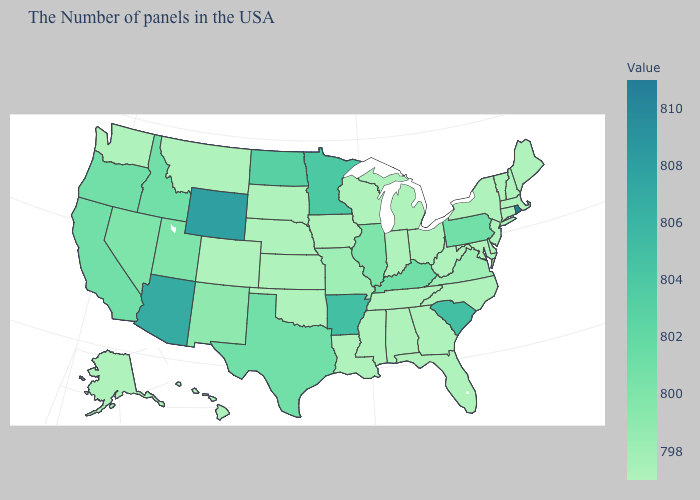Which states have the highest value in the USA?
Give a very brief answer. Rhode Island. Does Illinois have a higher value than Wisconsin?
Give a very brief answer. Yes. Which states have the highest value in the USA?
Be succinct. Rhode Island. Does Ohio have the highest value in the MidWest?
Quick response, please. No. Which states have the lowest value in the Northeast?
Write a very short answer. Maine, Massachusetts, New Hampshire, Vermont, Connecticut, New York, New Jersey. Does Florida have a lower value than Arkansas?
Write a very short answer. Yes. Does New Jersey have the highest value in the Northeast?
Be succinct. No. Does Hawaii have a lower value than Idaho?
Be succinct. Yes. Does the map have missing data?
Give a very brief answer. No. 